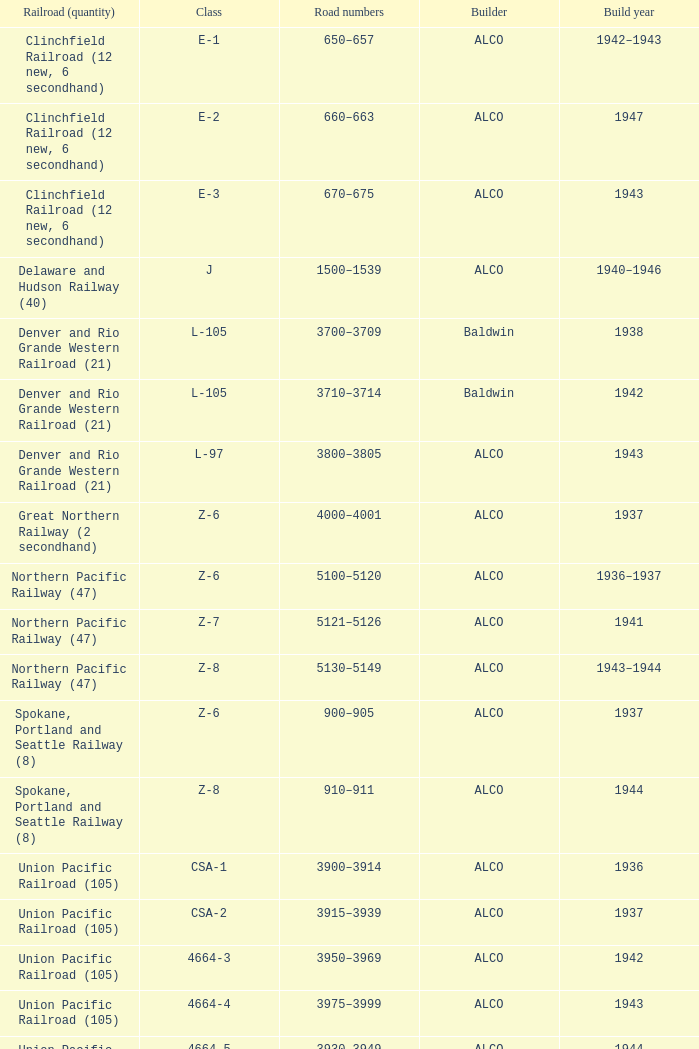What is the road numbers when the build year is 1943, the railroad (quantity) is clinchfield railroad (12 new, 6 secondhand)? 670–675. 